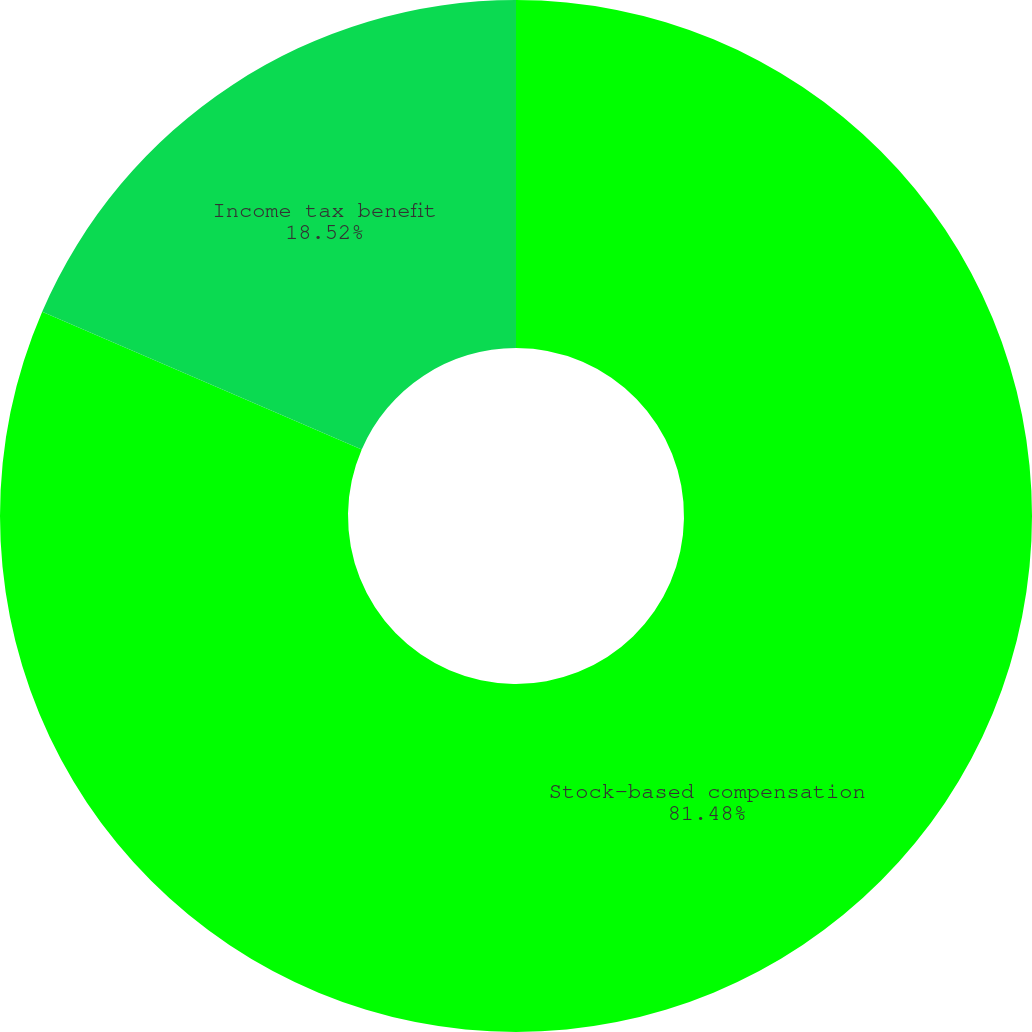<chart> <loc_0><loc_0><loc_500><loc_500><pie_chart><fcel>Stock-based compensation<fcel>Income tax benefit<nl><fcel>81.48%<fcel>18.52%<nl></chart> 